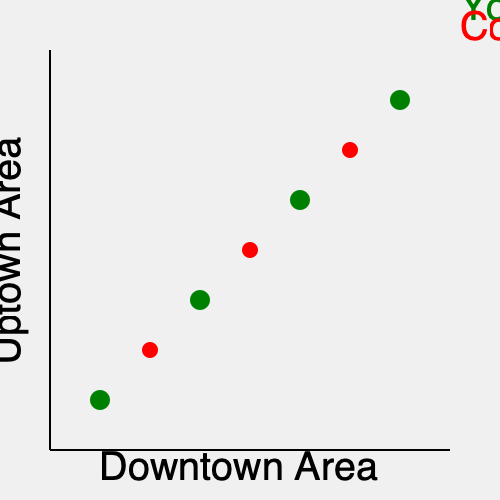Based on the geographic distribution of your smoothie bars and competing coffee houses shown in the map, what strategy should you consider to increase your market share in the uptown area? To answer this question, we need to analyze the current distribution of smoothie bars and coffee houses, and identify potential opportunities for expansion. Let's break it down step-by-step:

1. Current distribution:
   - Your smoothie bars (green circles) are located at coordinates (100, 400), (200, 300), (300, 200), and (400, 100).
   - Competing coffee houses (red circles) are at (150, 350), (250, 250), and (350, 150).

2. Market coverage:
   - Your smoothie bars form a diagonal line from the lower left to the upper right of the map.
   - Coffee houses also form a similar diagonal line, slightly offset from your locations.

3. Identifying gaps:
   - There's a noticeable gap in the uptown area (upper left quadrant of the map) where neither smoothie bars nor coffee houses are present.

4. Population density assumption:
   - Without specific population data, we can assume that both downtown and uptown areas have significant foot traffic and potential customers.

5. Competitive advantage:
   - Opening a new location in the uptown area would give you a first-mover advantage in that part of the city.

6. Strategic considerations:
   - A new location around coordinates (100, 100) or (150, 150) would fill the gap in your coverage.
   - This move would also position you to compete directly with coffee houses by offering a healthy alternative in an area they haven't yet penetrated.

Given these factors, the most strategic move to increase market share in the uptown area would be to open a new smoothie bar location in the upper left quadrant of the map. This would allow you to:
   a) Capture untapped market potential in the uptown area
   b) Establish presence before coffee houses expand there
   c) Create a more comprehensive citywide coverage for your brand
Answer: Open a new smoothie bar in the upper left quadrant (uptown area) of the map. 